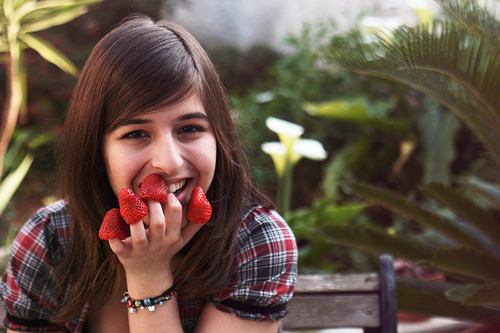<image>
Is the strawberry under the girl? No. The strawberry is not positioned under the girl. The vertical relationship between these objects is different. Is there a strawberries behind the girl? No. The strawberries is not behind the girl. From this viewpoint, the strawberries appears to be positioned elsewhere in the scene. Where is the strawberry in relation to the finger? Is it on the finger? Yes. Looking at the image, I can see the strawberry is positioned on top of the finger, with the finger providing support. 